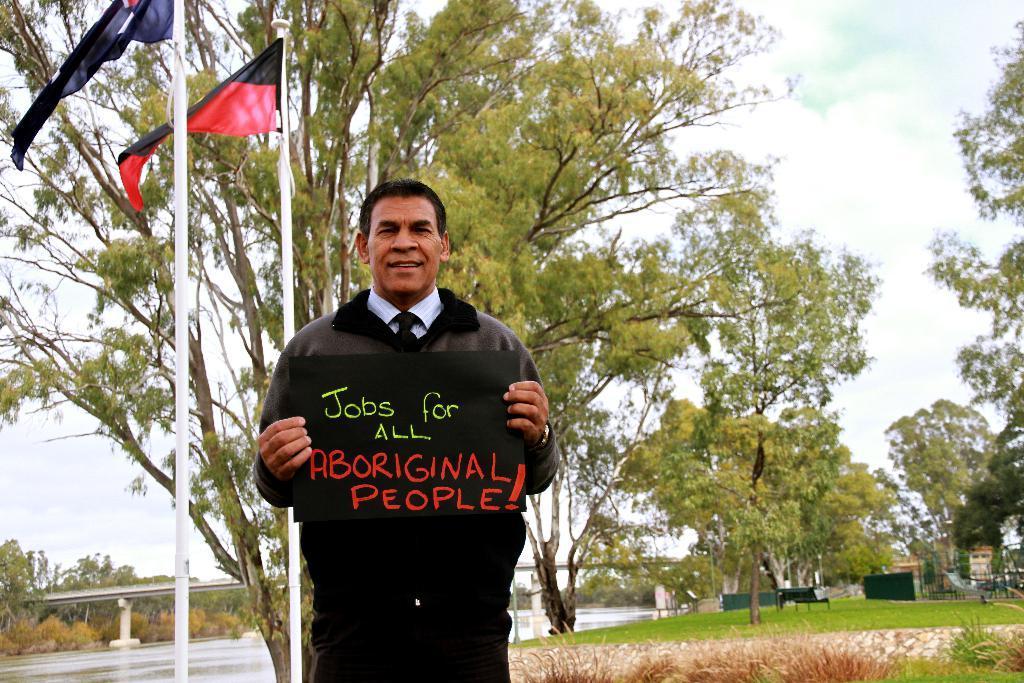Describe this image in one or two sentences. In this image I can see a person wearing black colored jacket is standing and holding black colored board in his hand. In the background I can see two flags, some grass, few trees, abridge, some water and the sky. 